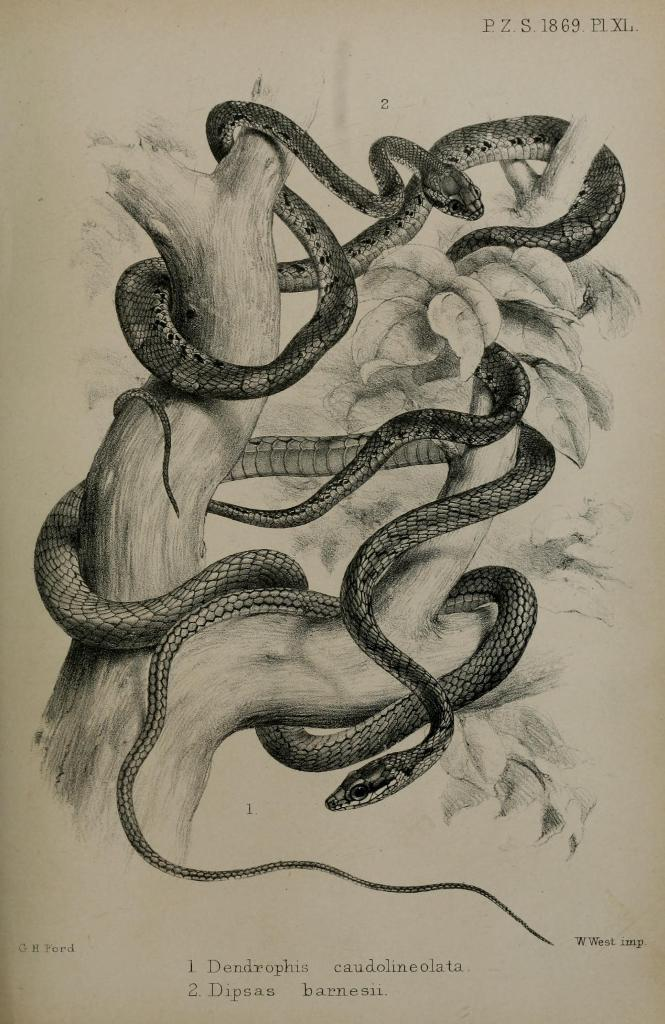What type of visual is the image? The image is a poster. What is depicted on the poster? There are depictions of snakes on a tree in the image. Is there any text present on the poster? Yes, there is text on the image. How many pairs of shoes are visible in the image? There are no shoes present in the image. What type of prose can be read in the image? There is no prose present in the image; it is a poster with depictions of snakes on a tree and text. 